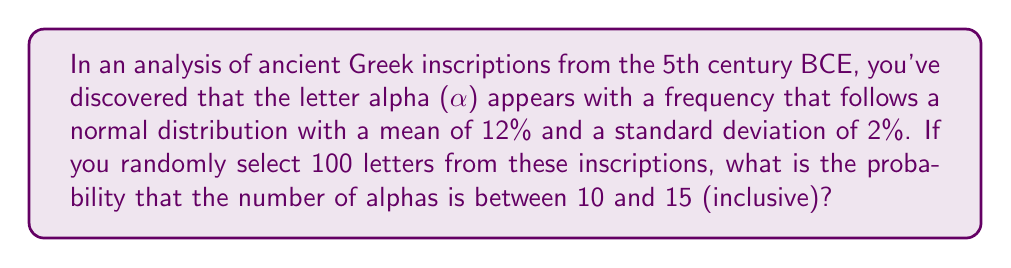Help me with this question. Let's approach this step-by-step:

1) Let X be the random variable representing the number of alphas in 100 randomly selected letters.

2) Given:
   - The frequency of alpha follows a normal distribution
   - Mean frequency (μ) = 12%
   - Standard deviation (σ) = 2%
   - Sample size (n) = 100

3) For a large sample size (n ≥ 30), we can approximate the binomial distribution with a normal distribution:
   X ~ N(nμ, √(nμ(1-μ)))

4) Calculate the mean and standard deviation of X:
   Mean of X = nμ = 100 * 0.12 = 12
   Variance of X = nμ(1-μ) = 100 * 0.12 * 0.88 = 10.56
   Standard deviation of X = √10.56 ≈ 3.25

5) We need to find P(10 ≤ X ≤ 15)

6) Standardize the random variable:
   Z = (X - μ) / σ
   For X = 10: Z1 = (10 - 12) / 3.25 ≈ -0.62
   For X = 15: Z2 = (15 - 12) / 3.25 ≈ 0.92

7) Use the standard normal distribution to find:
   P(10 ≤ X ≤ 15) = P(-0.62 ≤ Z ≤ 0.92)
                  = Φ(0.92) - Φ(-0.62)
                  = Φ(0.92) - (1 - Φ(0.62))
                  = 0.8212 - (1 - 0.7324)
                  = 0.8212 - 0.2676
                  = 0.5536

Where Φ is the cumulative distribution function of the standard normal distribution.
Answer: 0.5536 